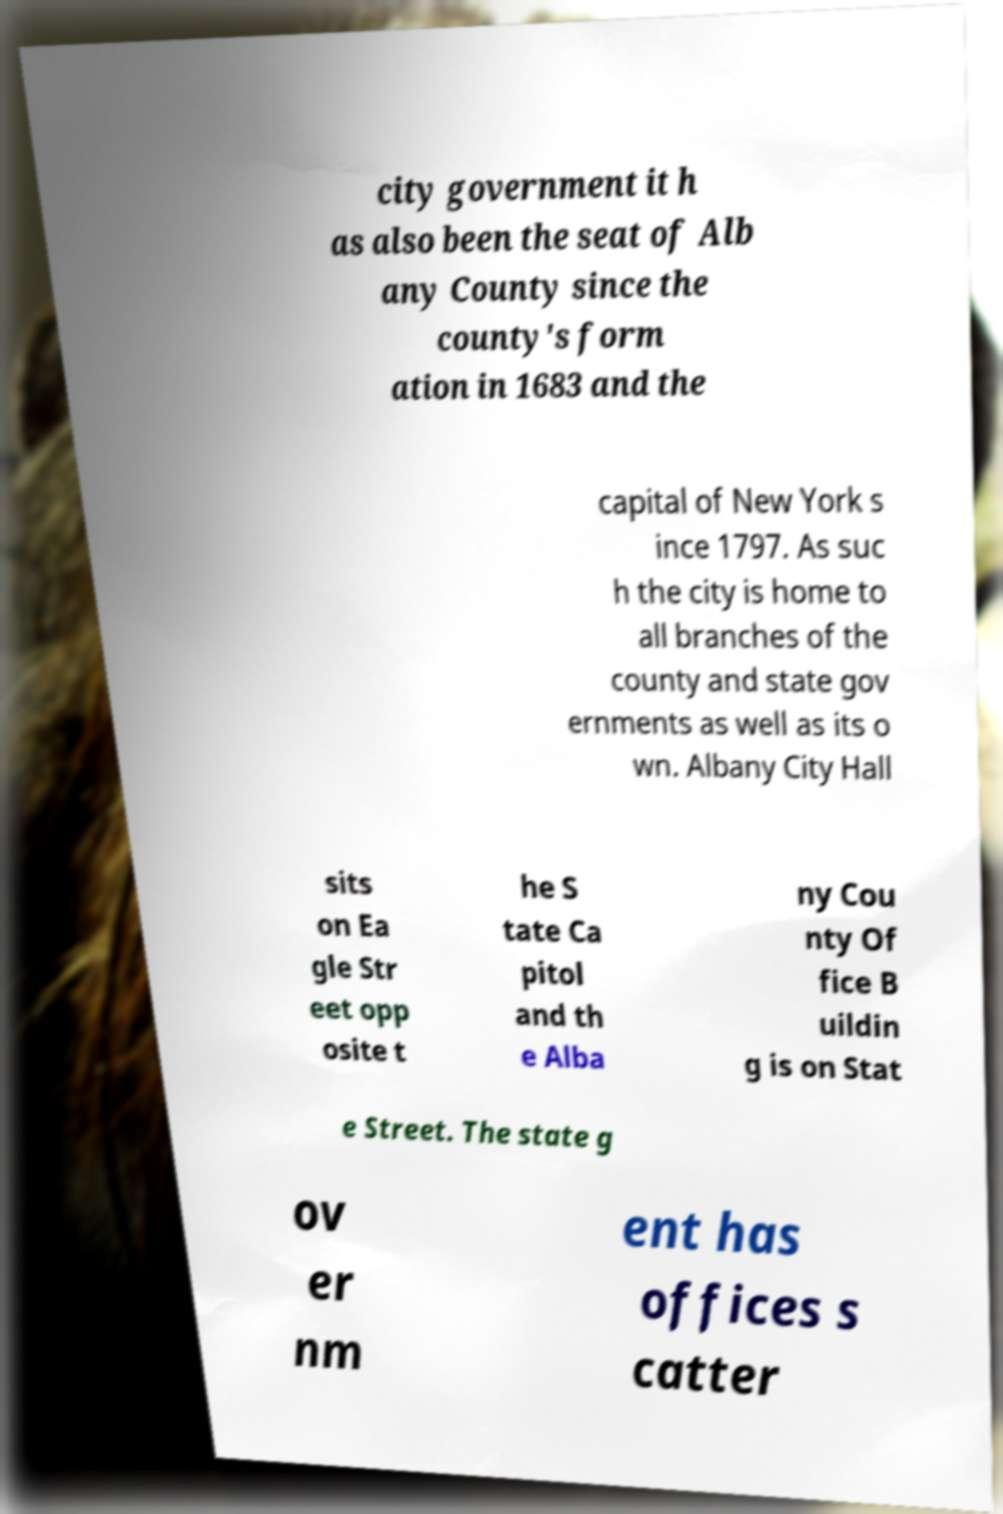For documentation purposes, I need the text within this image transcribed. Could you provide that? city government it h as also been the seat of Alb any County since the county's form ation in 1683 and the capital of New York s ince 1797. As suc h the city is home to all branches of the county and state gov ernments as well as its o wn. Albany City Hall sits on Ea gle Str eet opp osite t he S tate Ca pitol and th e Alba ny Cou nty Of fice B uildin g is on Stat e Street. The state g ov er nm ent has offices s catter 